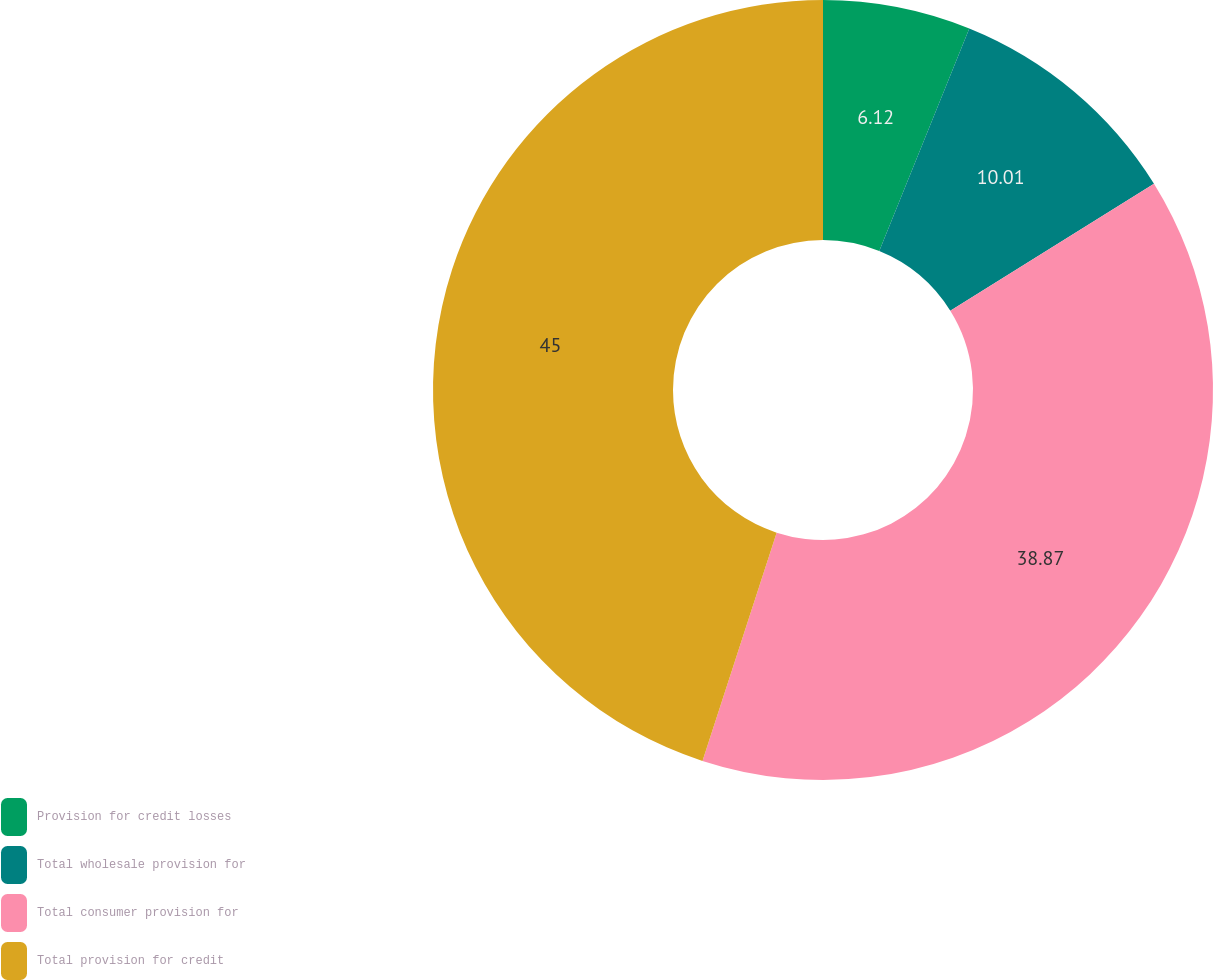Convert chart. <chart><loc_0><loc_0><loc_500><loc_500><pie_chart><fcel>Provision for credit losses<fcel>Total wholesale provision for<fcel>Total consumer provision for<fcel>Total provision for credit<nl><fcel>6.12%<fcel>10.01%<fcel>38.87%<fcel>45.0%<nl></chart> 